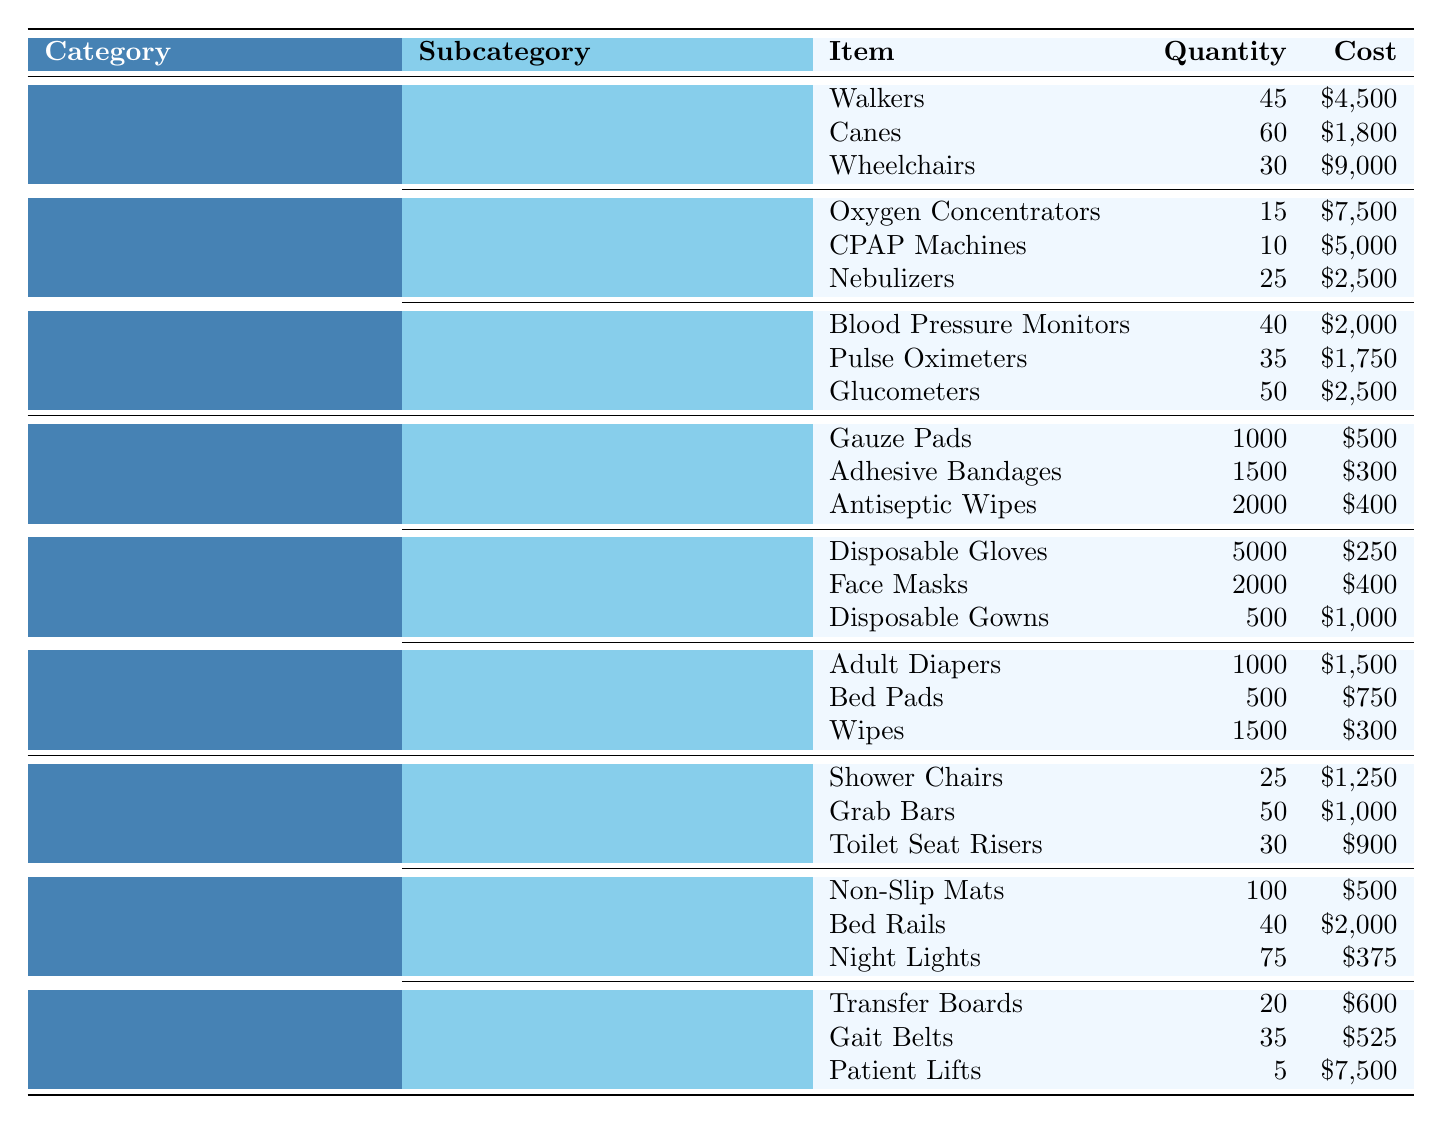What is the total quantity of Mobility Aids? The total quantity of Mobility Aids can be found by adding the quantities of all items in that subcategory: 45 (Walkers) + 60 (Canes) + 30 (Wheelchairs) = 135.
Answer: 135 How much does the total cost of Medical Supplies amount to? To find the total cost of Medical Supplies, we sum the costs of all items across the three subcategories: $500 (Wound Care) + $300 + $400 + $250 (Personal Protective Equipment) + $400 + $1,000 + $1,500 (Incontinence Products) + $750 + $300 = $5,600.
Answer: $5,600 Is there a higher quantity of Adult Diapers than Disposable Gloves? The quantity of Adult Diapers is 1,000, while Disposable Gloves are 5,000. Since 1,000 is less than 5,000, the answer is no.
Answer: No What is the average cost of items in the Respiratory Equipment subcategory? The average cost can be calculated by summing the costs and dividing by the number of items: ($7,500 + $5,000 + $2,500) = $15,000 total cost, divided by 3 items gives an average of $5,000.
Answer: $5,000 Which category has the highest total quantity of items, and what is that quantity? We need to total the quantity of items in each category. Medical Equipment: 45 + 60 + 30 + 15 + 10 + 25 + 40 + 35 + 50 = 365. Medical Supplies: 1,000 + 1,500 + 2,000 + 5,000 + 2,000 + 500 + 1,000 + 500 + 1,500 + 300 = 15,300. Home Safety Equipment: 25 + 50 + 30 + 100 + 40 + 75 + 20 + 35 + 5 = 380. Comparing these, Medical Supplies has the highest total quantity, which is 15,300.
Answer: Medical Supplies, 15,300 How much more is the total cost of Home Safety Equipment than the total cost of Medical Equipment? First, calculate the total cost of Home Safety Equipment: $1,250 (Bathroom Safety) + $1,000 + $900 + $500 (Fall Prevention) + $2,000 + $375 + $600 (Transfer Aids) + $525 + $7,500 = $15,150. The total cost of Medical Equipment is $4,500 + $1,800 + $9,000 + $7,500 + $5,000 + $2,500 = $30,300. The difference is $30,300 - $15,150 = $15,150.
Answer: $15,150 